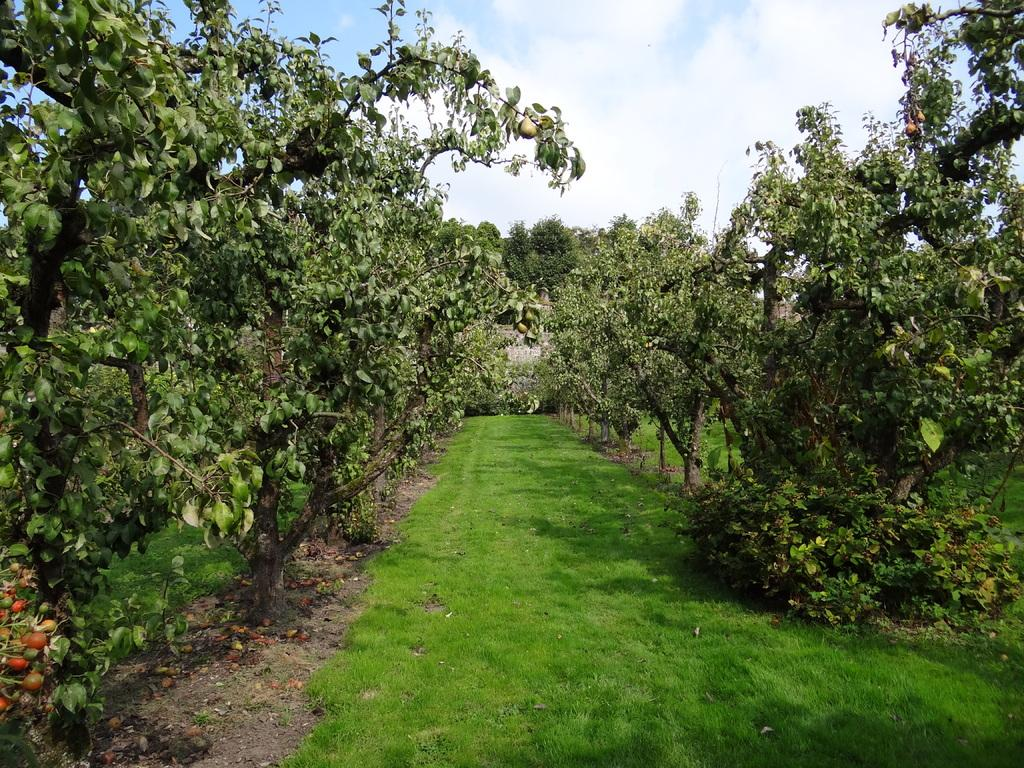What type of vegetation is present in the image? There is grass and trees in the image. What can be seen in the background of the image? There is a building in the background of the image. What is visible at the top of the image? The sky is visible at the top of the image. Where is the servant standing in the image? There is no servant present in the image. What type of seed can be seen growing in the image? There is no seed visible in the image. 